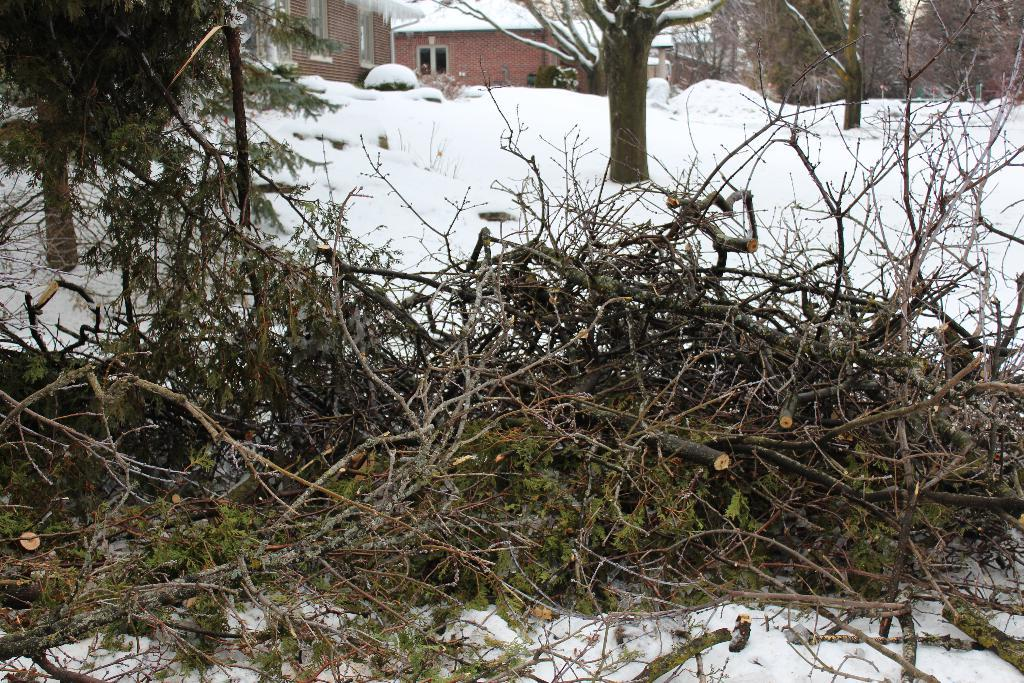What is on top of the snow in the image? There are branches on the snow in the image. What can be seen in the distance behind the snow? There are trees, buildings, and plants in the background of the image. What statement does the snow make to the trees in the image? The snow does not make any statements in the image; it is an inanimate object. 